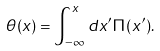<formula> <loc_0><loc_0><loc_500><loc_500>\theta ( x ) = \int _ { - \infty } ^ { x } d x ^ { \prime } \Pi ( x ^ { \prime } ) .</formula> 